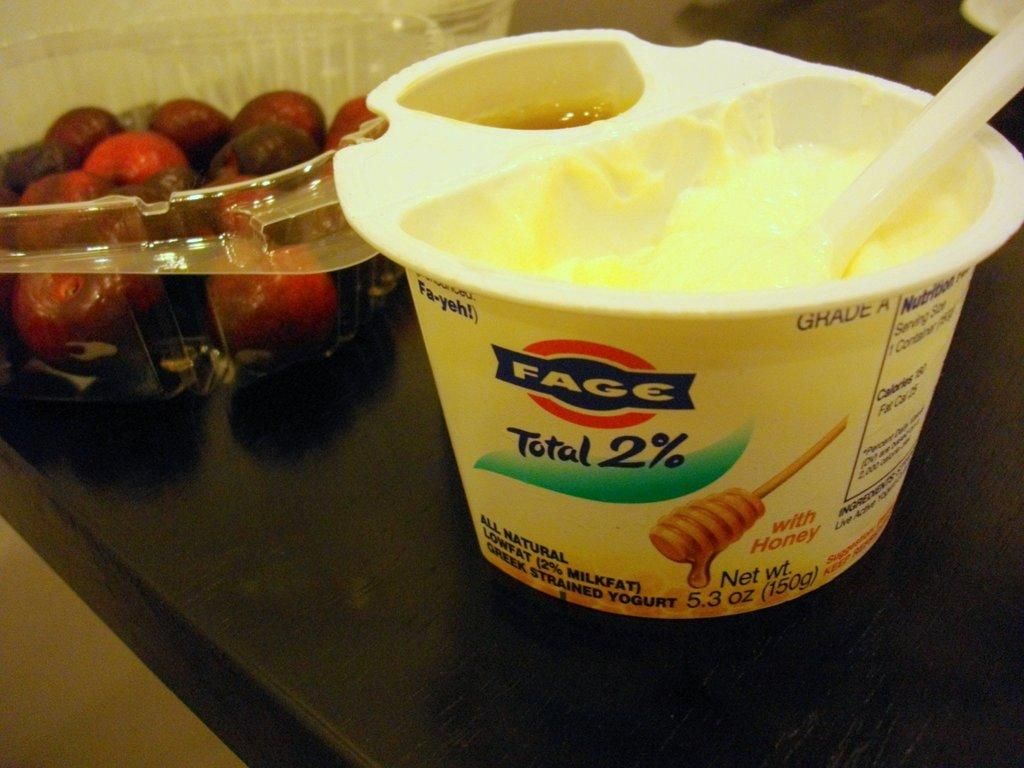What is the main subject of the image? The main subject of the image is food. Where is the food located in the image? The food is in the center of the image. What color is the surface beneath the food? The surface beneath the food is black in color. How many tin clocks are present in the image? There are no tin clocks present in the image. 